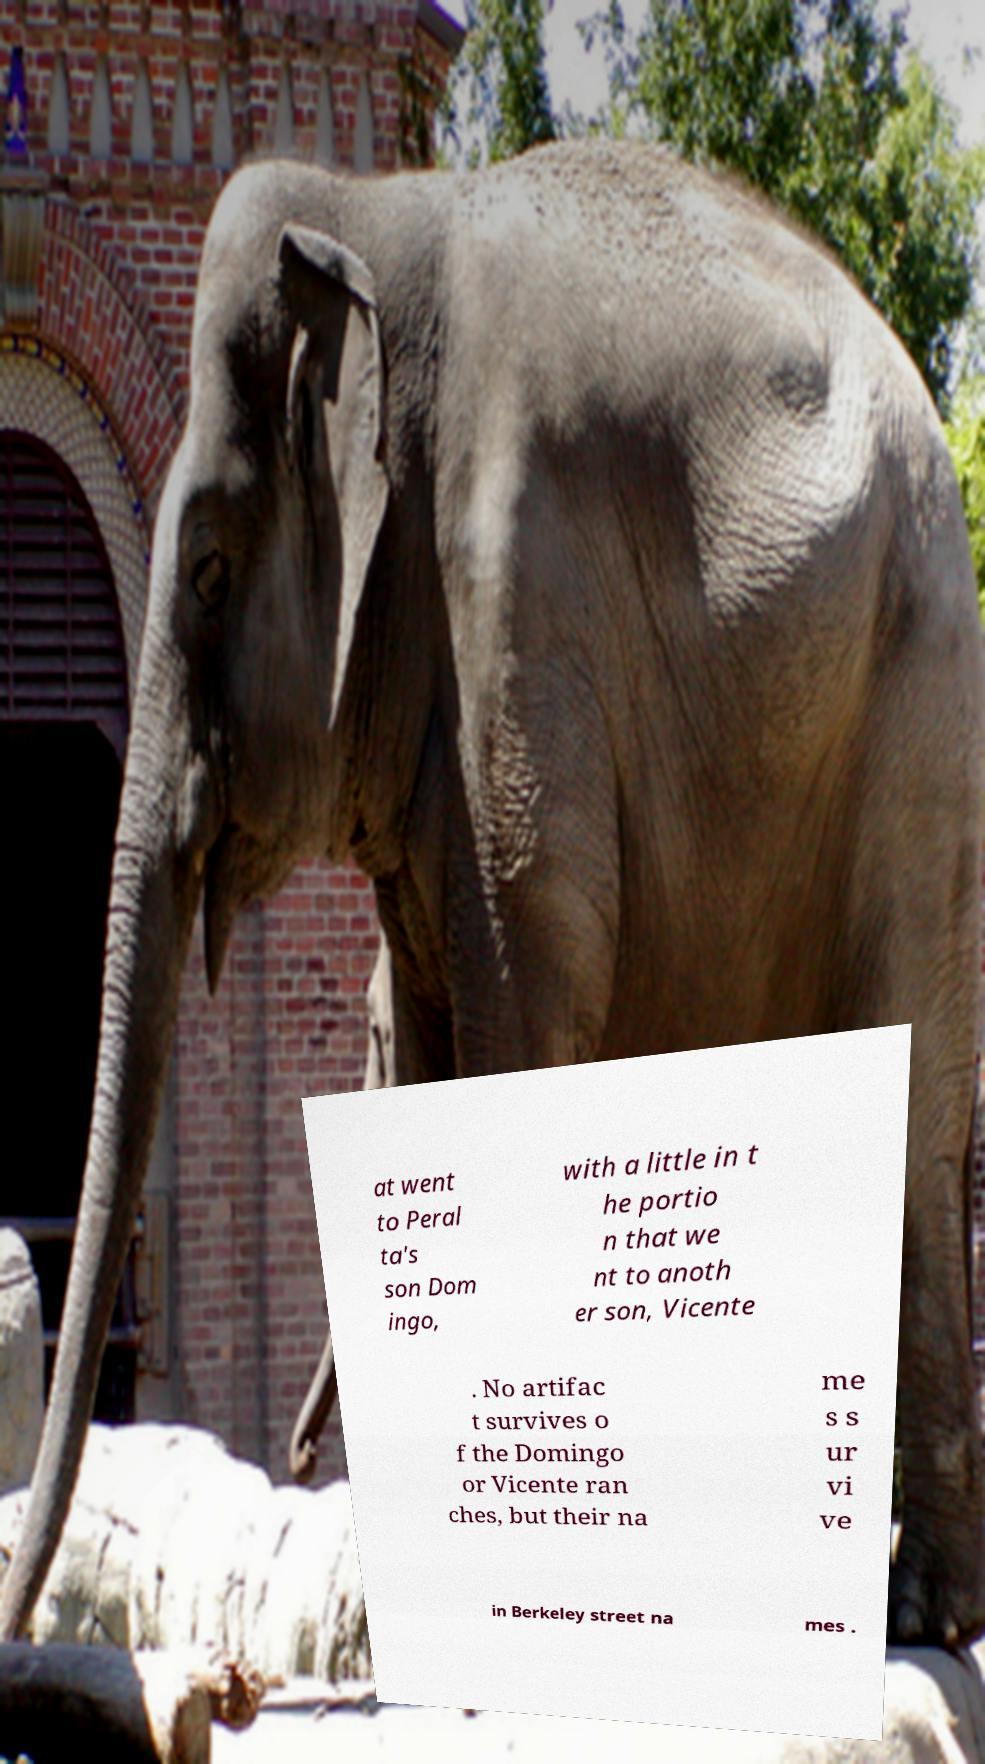I need the written content from this picture converted into text. Can you do that? at went to Peral ta's son Dom ingo, with a little in t he portio n that we nt to anoth er son, Vicente . No artifac t survives o f the Domingo or Vicente ran ches, but their na me s s ur vi ve in Berkeley street na mes . 